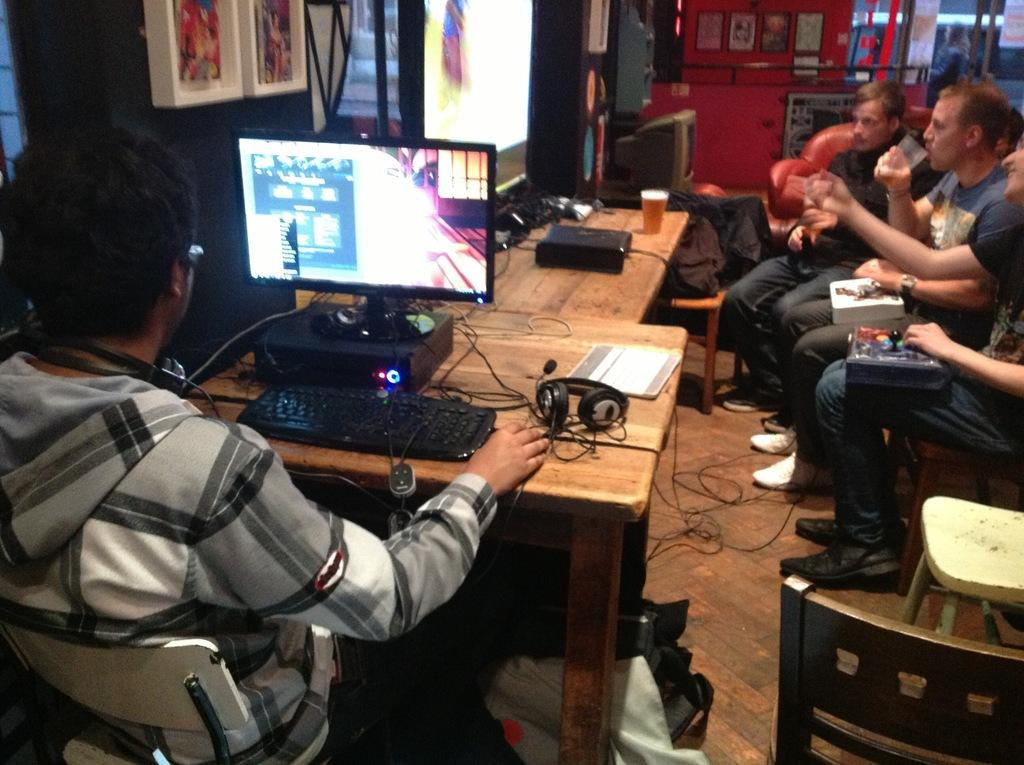Who or what can be seen in the image? There are people in the image. What are the people doing in the image? The people are sitting on chairs. What type of marble is being used to play a game in the image? There is no marble or game present in the image; it features people sitting on chairs. Can you see a robin perched on the back of one of the chairs in the image? There is no robin present in the image. 